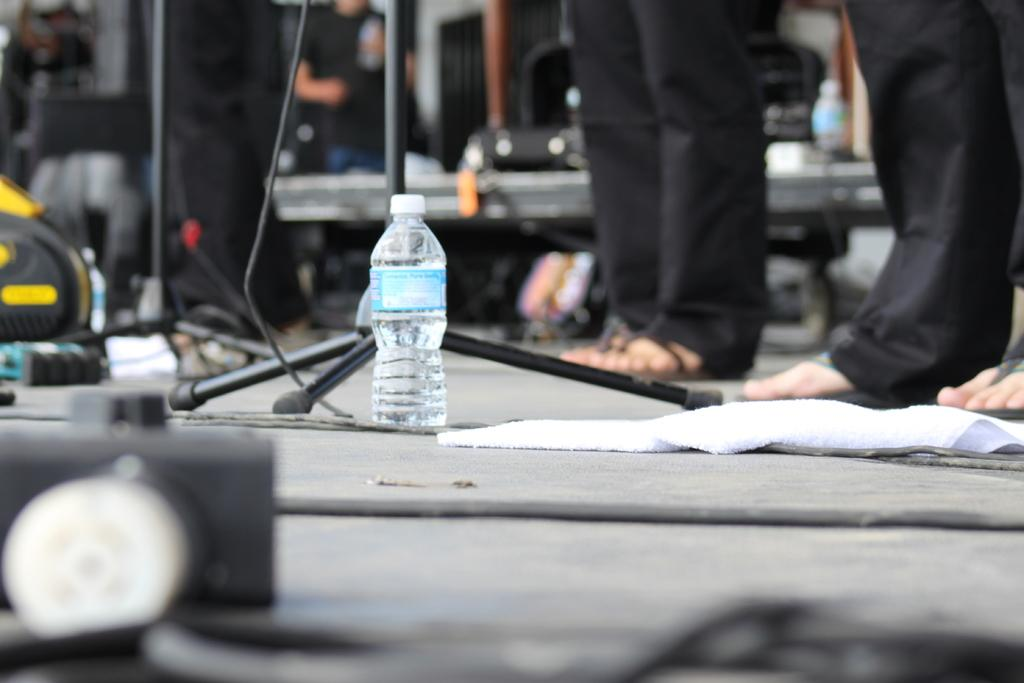What is the person in the image doing? The person is standing in the image. Where is the person standing? The person is standing on the ground. What object is in front of the person? There is a water bottle in front of the person. What structure can be seen in the image? There is a stand in the image. What type of material is present in the image? There is a cloth in the image. Is the person playing a game of hot power in the image? There is no indication of a game being played in the image, and the terms "hot" and "power" are not relevant to the scene depicted. 